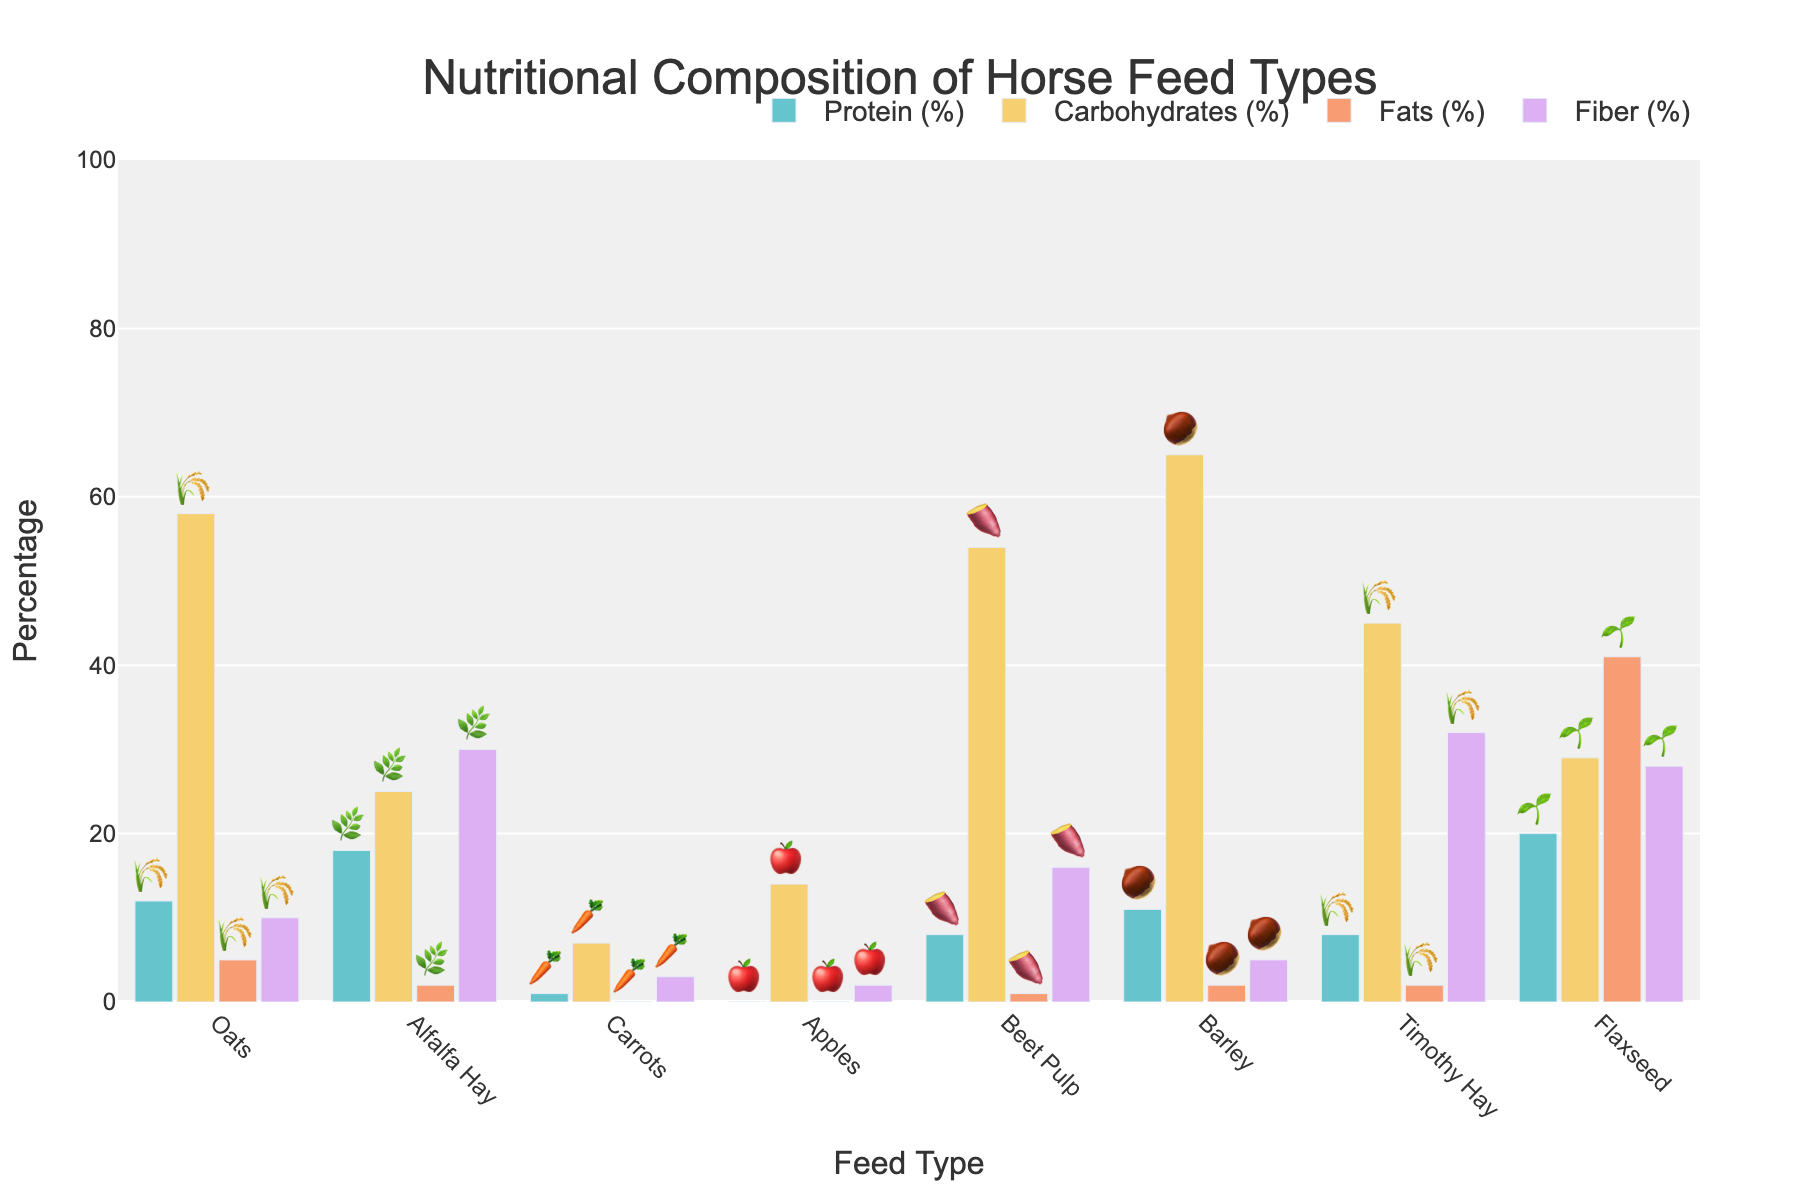what is the title of the chart? The title is typically found at the top of the chart. It provides a summary of the data represented in the figure.
Answer: Nutritional Composition of Horse Feed Types What feed type contains the highest percentage of protein? Look at the "Protein (%)" bars for each feed type and identify the one which has the highest value.
Answer: Flaxseed How much higher is the carbohydrate content in Barley compared to Oats? Check the "Carbohydrates (%)" bars for Barley and Oats, then subtract the carbohydrate percentage of Oats from that of Barley (65% - 58%).
Answer: 7% Which feed type has the lowest fat content? Look at the "Fats (%)" bars for each feed type and identify the one which has the lowest value.
Answer: Carrots / Apples What is the sum of the fiber percentages for Alfalfa Hay and Timothy Hay? Add the fiber percentage of Alfalfa Hay (30%) to that of Timothy Hay (32%) to get the total.
Answer: 62% Which feed type has a higher fiber content: Beet Pulp or Flaxseed? Compare the "Fiber (%)" bars for Beet Pulp and Flaxseed to see which one is higher.
Answer: Flaxseed Which feed type provides the most balanced distribution of macronutrients? Look at the distribution of Protein, Carbohydrates, Fats, and Fiber for each feed type and identify which one has a more equal spread across different nutrients.
Answer: Oats What is the average fat percentage for all the feed types? To find this, add up the fat percentages for all feed types and divide by the number of feed types [(5+2+0+0+1+2+2+41)/8].
Answer: 6.625% How do the carbohydrate percentages of Beet Pulp and Timothy Hay compare? Look at the "Carbohydrates (%)" bars for Beet Pulp and Timothy Hay and compare their values.
Answer: Beet Pulp is higher Which feed type represented by the emoji '🥕' has a protein content of 1%? Look at the emojis with their corresponding feed types and percentages; '🥕' correlates with Carrots.
Answer: Carrots 